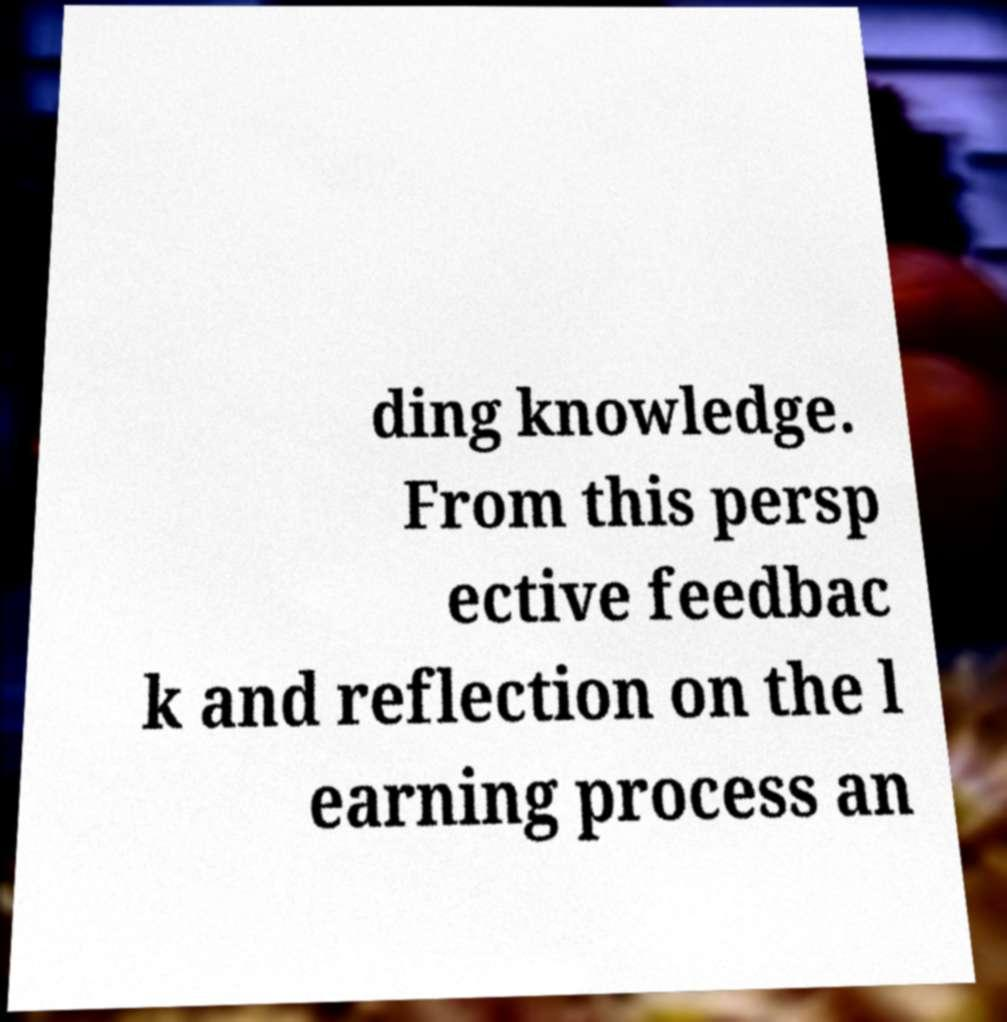Please read and relay the text visible in this image. What does it say? ding knowledge. From this persp ective feedbac k and reflection on the l earning process an 